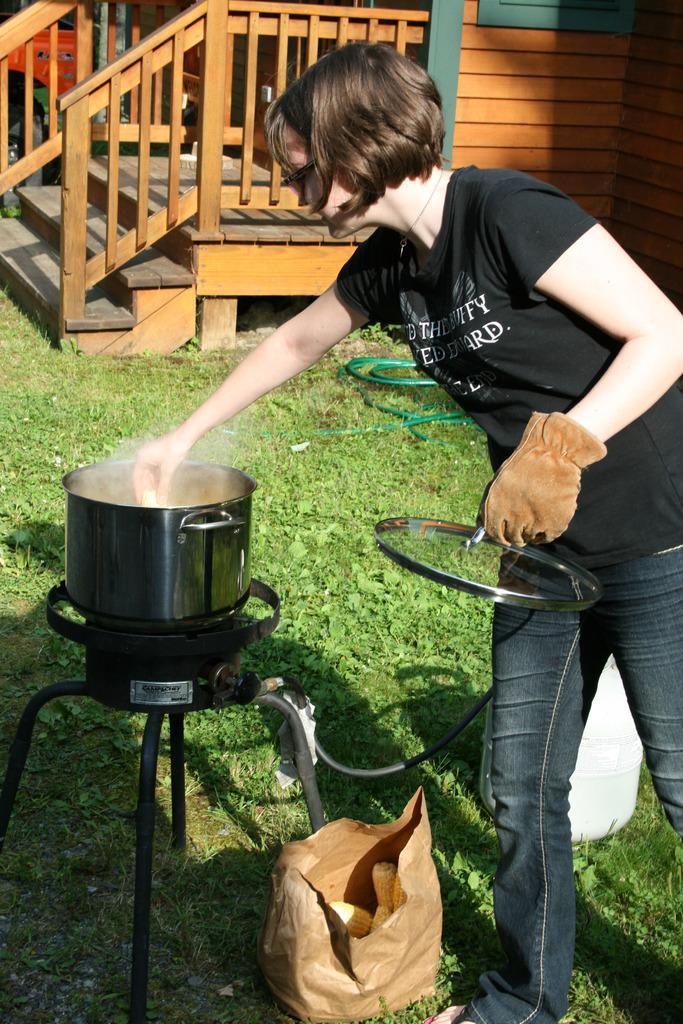Please provide a concise description of this image. In this picture there is a lady who is standing on the right side of the image and there is a stove on the left side of the image, she is cooking and there is staircase at the top side of the image, there is grassland at the bottom side of the image. 